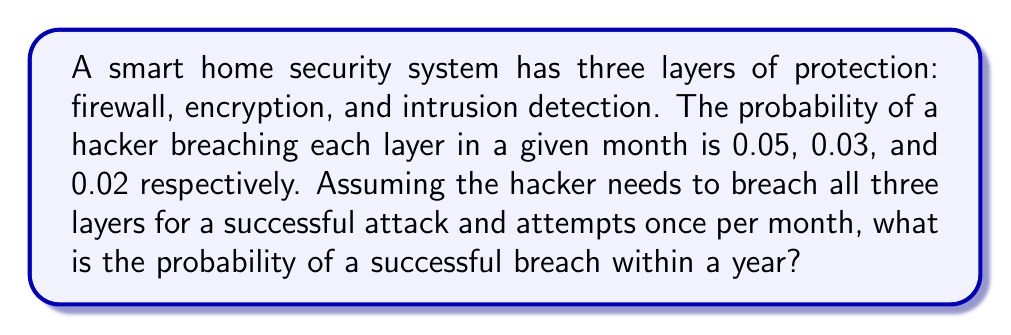Can you answer this question? 1. First, let's calculate the probability of a successful breach in a single attempt:
   $P(\text{success}) = 0.05 \times 0.03 \times 0.02 = 0.00003$

2. Now, we need to find the probability of at least one successful breach in 12 attempts (12 months):
   $P(\text{at least one success}) = 1 - P(\text{no success in 12 attempts})$

3. The probability of no success in a single attempt:
   $P(\text{no success}) = 1 - 0.00003 = 0.99997$

4. The probability of no success in 12 independent attempts:
   $P(\text{no success in 12 attempts}) = (0.99997)^{12}$

5. Finally, we can calculate the probability of at least one success:
   $$\begin{align}
   P(\text{at least one success}) &= 1 - (0.99997)^{12} \\
   &= 1 - 0.99964 \\
   &\approx 0.00036
   \end{align}$$

6. Convert to percentage:
   $0.00036 \times 100\% = 0.036\%$
Answer: 0.036% 